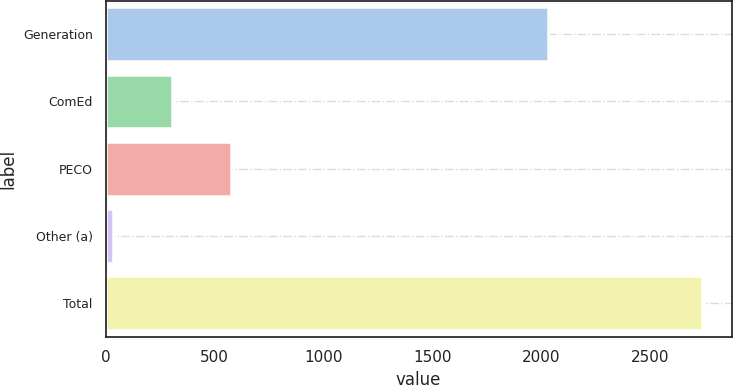<chart> <loc_0><loc_0><loc_500><loc_500><bar_chart><fcel>Generation<fcel>ComEd<fcel>PECO<fcel>Other (a)<fcel>Total<nl><fcel>2029<fcel>305.1<fcel>575.2<fcel>35<fcel>2736<nl></chart> 